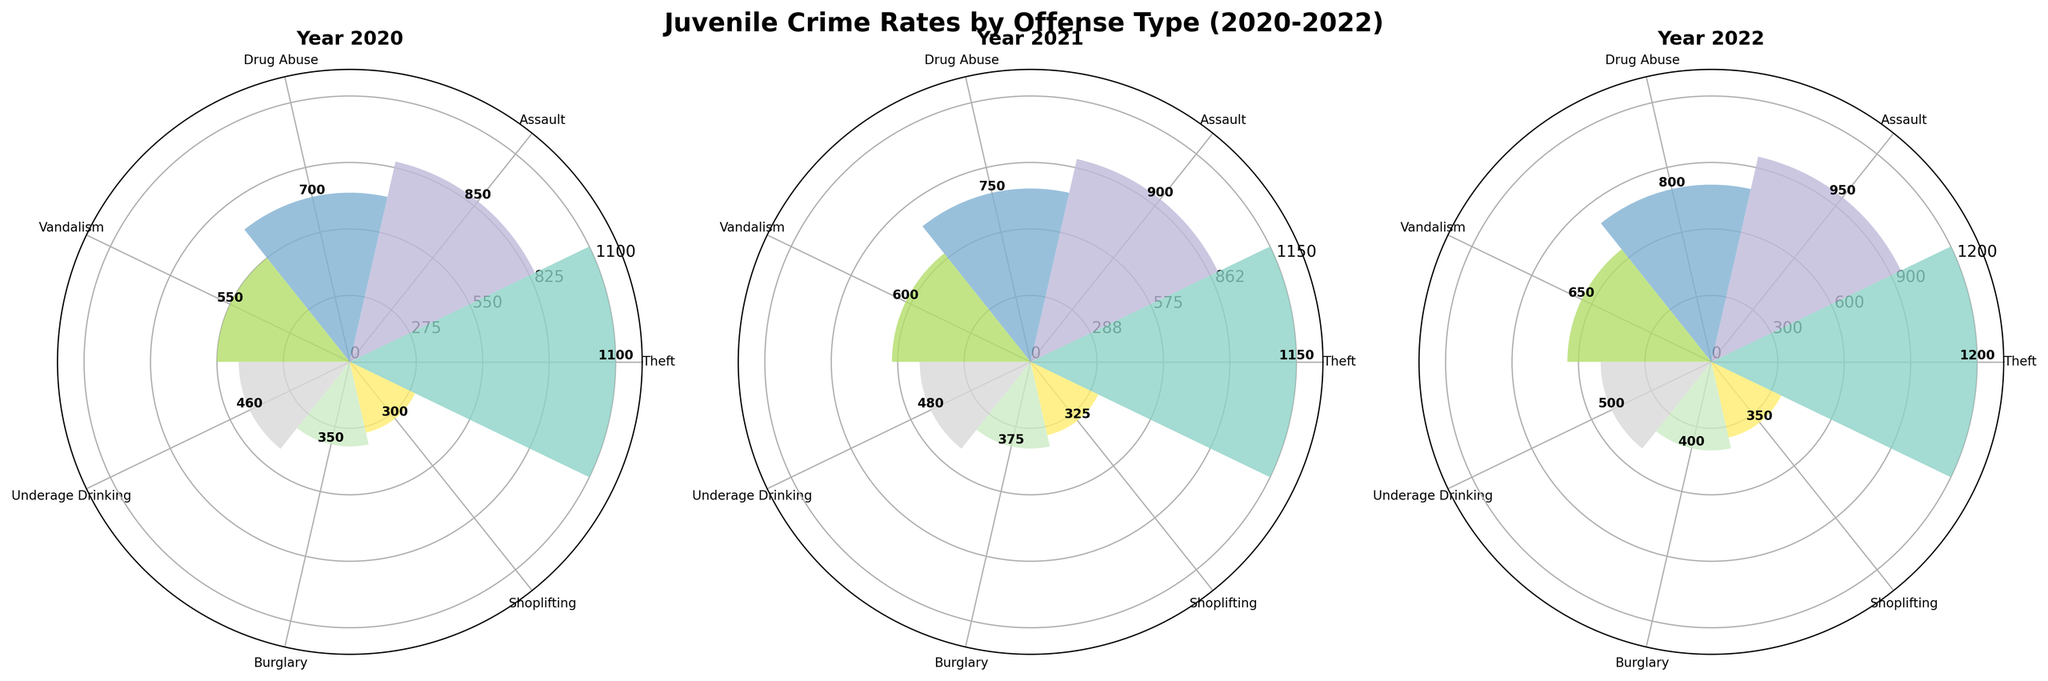How many offense types are represented in the figures? Each subplot (representing a year) has distinct bars, each labeled with an offense type. Counting these labels gives the number of offense types.
Answer: 7 Which year had the highest number of arrests for theft? By examining the height of the bars labeled "Theft" in each subplot, we can see which year's bar is tallest, indicating the highest number of arrests.
Answer: 2022 How do the arrests for assault in 2021 compare to those in 2020? Look at the heights of the bars labeled "Assault" for both 2020 and 2021 subplots. The 2021 bar is taller indicating a higher number of arrests compared to 2020.
Answer: Higher in 2021 What is the average number of arrests for vandalism over the three years? Add the number of arrests for vandalism from each year (650 + 600 + 550) and divide by 3 to get the average.
Answer: 600 Which offense type shows the most significant decrease in arrests from 2020 to 2022? Compare the heights of the bars from 2020 to 2022 for each offense type and identify which one has the largest decrease.
Answer: Shoplifting In which year were arrests for underage drinking the lowest? Compare the heights of the "Underage Drinking" bars across all three subplots to see which is the shortest, indicating the fewest arrests.
Answer: 2020 What is the sum of arrests for drug abuse across all three years? Add the number of arrests for drug abuse for each year (800 + 750 + 700) to get the total.
Answer: 2250 Is the overall trend of arrests for burglary increasing, decreasing, or stable from 2020 to 2022? By examining the heights of the bars labeled "Burglary" across the three years, we notice a decrease in height, indicating that arrests are decreasing.
Answer: Decreasing Which offense type had the smallest number of arrests in 2022? Among the bars representing 2022, identify the shortest one to determine the offense type with the fewest arrests.
Answer: Shoplifting How does the number of arrests for drug abuse in 2022 compare to that for theft in the same year? Compare the height of the bars for "Drug Abuse" and "Theft" in the 2022 subplot; "Theft" is taller indicating more arrests.
Answer: Fewer 